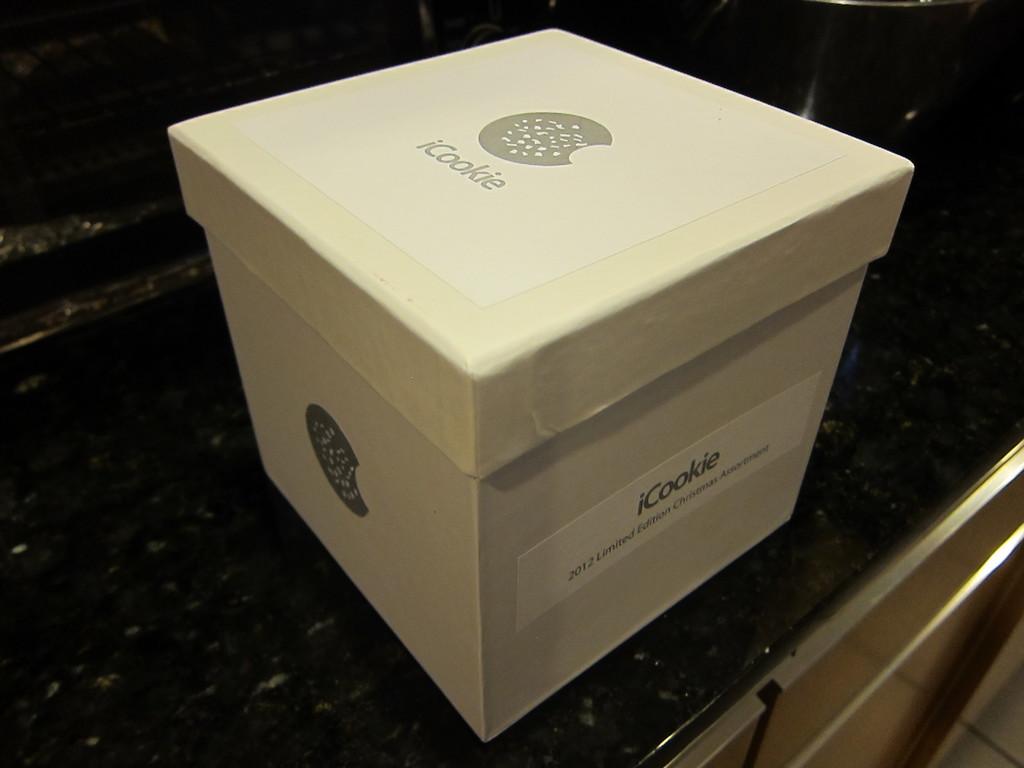What name is this on the box?
Keep it short and to the point. Icookie. What is the name of the manufacture of these boxes?
Give a very brief answer. Icookie. 